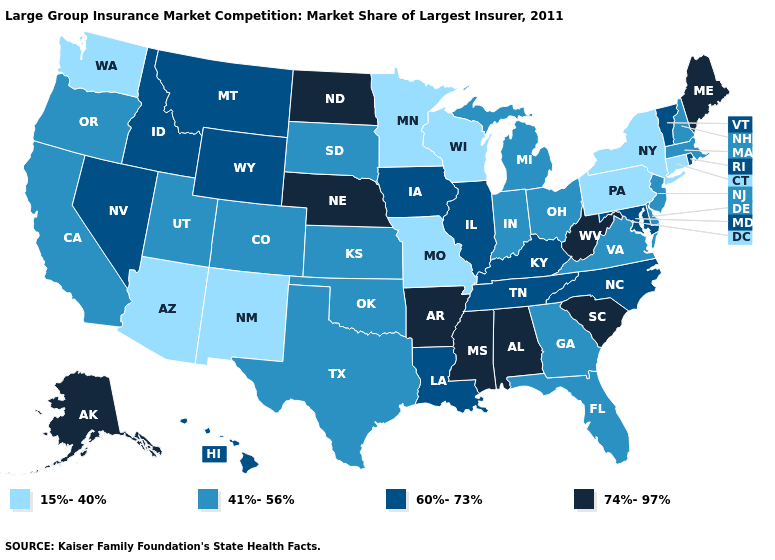Name the states that have a value in the range 15%-40%?
Give a very brief answer. Arizona, Connecticut, Minnesota, Missouri, New Mexico, New York, Pennsylvania, Washington, Wisconsin. What is the lowest value in the West?
Keep it brief. 15%-40%. What is the value of New Mexico?
Write a very short answer. 15%-40%. What is the lowest value in states that border Arkansas?
Keep it brief. 15%-40%. Does the first symbol in the legend represent the smallest category?
Short answer required. Yes. What is the lowest value in the MidWest?
Short answer required. 15%-40%. What is the value of Washington?
Answer briefly. 15%-40%. Name the states that have a value in the range 60%-73%?
Write a very short answer. Hawaii, Idaho, Illinois, Iowa, Kentucky, Louisiana, Maryland, Montana, Nevada, North Carolina, Rhode Island, Tennessee, Vermont, Wyoming. Which states hav the highest value in the South?
Write a very short answer. Alabama, Arkansas, Mississippi, South Carolina, West Virginia. Name the states that have a value in the range 15%-40%?
Short answer required. Arizona, Connecticut, Minnesota, Missouri, New Mexico, New York, Pennsylvania, Washington, Wisconsin. Among the states that border Delaware , does Pennsylvania have the lowest value?
Write a very short answer. Yes. Does the map have missing data?
Write a very short answer. No. What is the value of Oregon?
Short answer required. 41%-56%. What is the value of Pennsylvania?
Answer briefly. 15%-40%. 